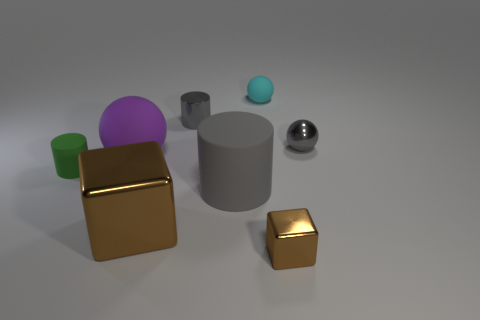The matte ball left of the small gray object to the left of the small gray metal sphere that is behind the big brown shiny block is what color?
Your answer should be very brief. Purple. Does the cyan matte object have the same size as the rubber cylinder that is to the left of the big gray thing?
Keep it short and to the point. Yes. How many objects are large matte things behind the large gray rubber object or cylinders to the left of the large cube?
Your answer should be very brief. 2. There is a brown object that is the same size as the cyan ball; what is its shape?
Provide a short and direct response. Cube. What is the shape of the gray thing that is in front of the small matte thing that is on the left side of the small gray metal thing to the left of the small cyan ball?
Provide a short and direct response. Cylinder. Are there the same number of big gray matte things that are behind the tiny metal cylinder and brown matte cylinders?
Provide a short and direct response. Yes. Does the cyan object have the same size as the purple sphere?
Offer a terse response. No. What number of matte objects are either cyan spheres or gray things?
Provide a succinct answer. 2. There is a brown object that is the same size as the purple rubber object; what is its material?
Ensure brevity in your answer.  Metal. How many other objects are the same material as the green cylinder?
Your response must be concise. 3. 